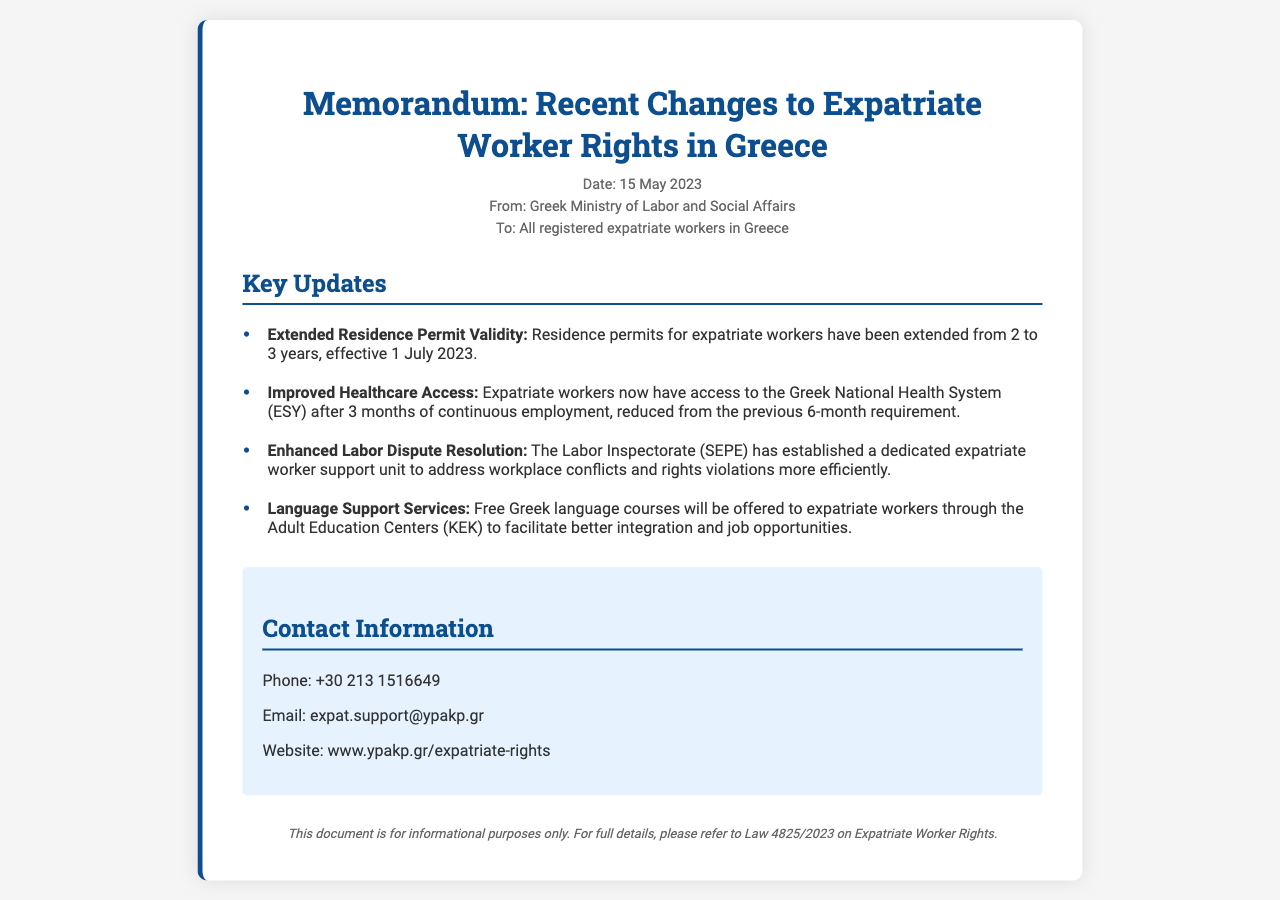what is the date of the memorandum? The date of the memorandum is stated in the meta-info section of the document.
Answer: 15 May 2023 who issued the document? The document is issued by the Greek Ministry of Labor and Social Affairs, as indicated in the meta-info.
Answer: Greek Ministry of Labor and Social Affairs what is the duration of the extended residence permit? The document provides information about the duration of the residence permit extension.
Answer: 3 years when will the new residence permit validity take effect? The document mentions the effective date for the extended residence permit validity.
Answer: 1 July 2023 how long was the previous requirement for healthcare access? The document specifies the previous duration for healthcare access before the new regulations.
Answer: 6 months what is the name of the dedicated support unit? The document describes the unit set up for expatriate workers within the Labor Inspectorate.
Answer: expatriate worker support unit how are expatriate workers supported in language learning? The document mentions the initiative for expatriate workers in learning the local language.
Answer: Free Greek language courses what is the phone number for expatriate support? The contact information section includes the phone number for expatriate workers seeking assistance.
Answer: +30 213 1516649 what does the footer indicate about the document? The footer provides clarified information regarding the purpose of the document.
Answer: informational purposes only 